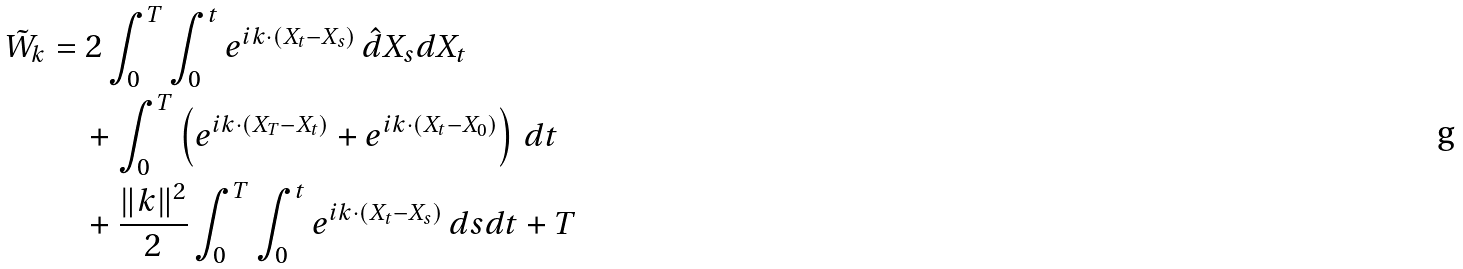Convert formula to latex. <formula><loc_0><loc_0><loc_500><loc_500>\tilde { W } _ { k } & = 2 \real \int _ { 0 } ^ { T } \int _ { 0 } ^ { t } e ^ { i k \cdot ( X _ { t } - X _ { s } ) } \, \hat { d } X _ { s } d X _ { t } \\ & \quad + \real \int _ { 0 } ^ { T } \left ( e ^ { i k \cdot ( X _ { T } - X _ { t } ) } + e ^ { i k \cdot ( X _ { t } - X _ { 0 } ) } \right ) \, d t \\ & \quad + \frac { \| k \| ^ { 2 } } { 2 } \real \int _ { 0 } ^ { T } \int _ { 0 } ^ { t } e ^ { i k \cdot ( X _ { t } - X _ { s } ) } \, d s d t + T \\</formula> 